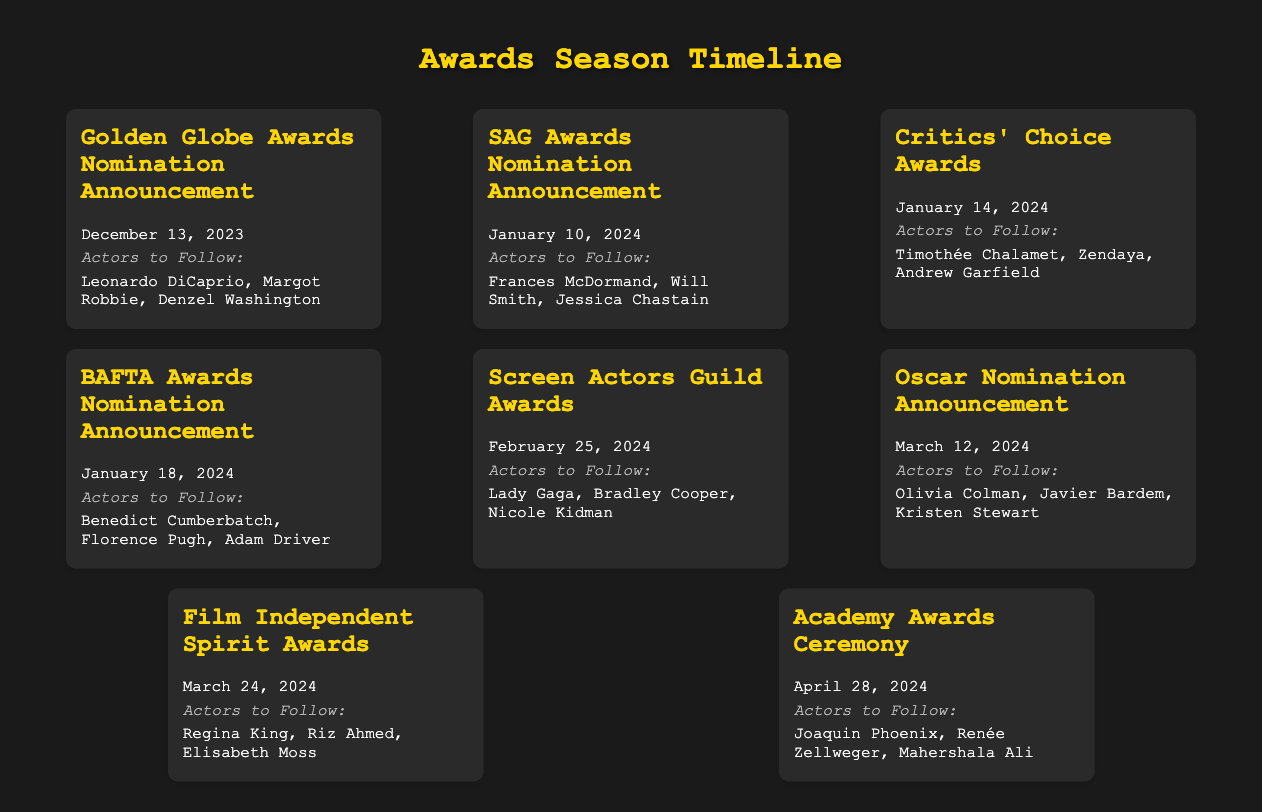What date is the Golden Globe Awards Nomination Announcement? The date is mentioned directly in the event description for the Golden Globe Awards Nomination Announcement.
Answer: December 13, 2023 Who are the actors to follow for the Critics' Choice Awards? The actors are listed under the Critics' Choice Awards event and include Timothée Chalamet, Zendaya, and Andrew Garfield.
Answer: Timothée Chalamet, Zendaya, Andrew Garfield What event occurs immediately after the SAG Awards Nomination Announcement? By referring to the timeline, the next event after the SAG Awards Nomination Announcement is the Critics' Choice Awards.
Answer: Critics' Choice Awards How many actors are listed for the BAFTA Awards Nomination Announcement? The number of actors mentioned is determined from the "actors to follow" section for the BAFTA Awards Nomination Announcement.
Answer: Three Which actor is mentioned under both the Screen Actors Guild Awards and the Academy Awards Ceremony? To find this, one would need to check both sections for overlapping actors' names.
Answer: None 